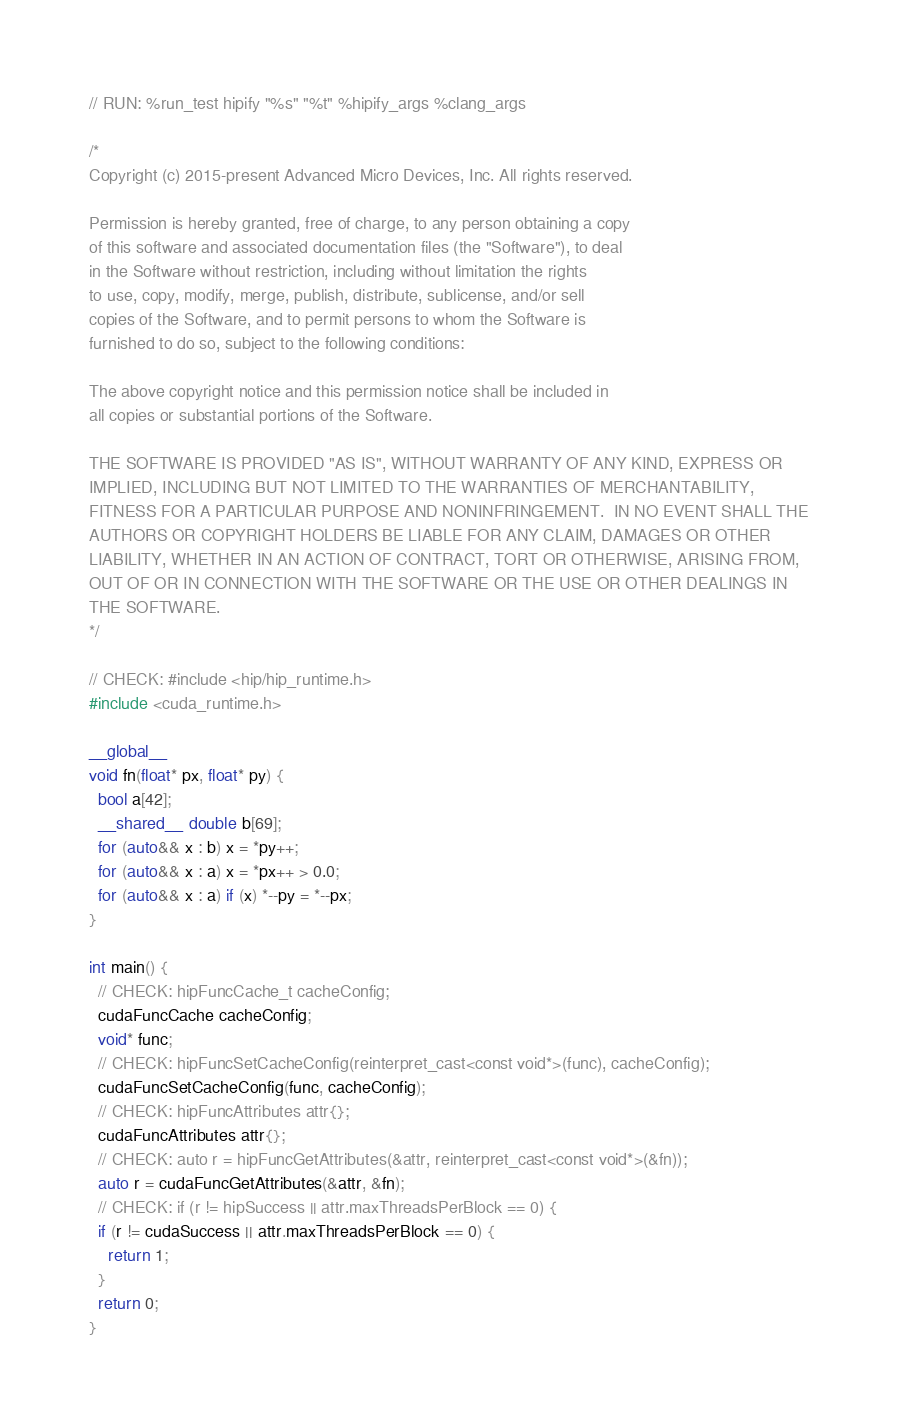<code> <loc_0><loc_0><loc_500><loc_500><_Cuda_>// RUN: %run_test hipify "%s" "%t" %hipify_args %clang_args

/*
Copyright (c) 2015-present Advanced Micro Devices, Inc. All rights reserved.

Permission is hereby granted, free of charge, to any person obtaining a copy
of this software and associated documentation files (the "Software"), to deal
in the Software without restriction, including without limitation the rights
to use, copy, modify, merge, publish, distribute, sublicense, and/or sell
copies of the Software, and to permit persons to whom the Software is
furnished to do so, subject to the following conditions:

The above copyright notice and this permission notice shall be included in
all copies or substantial portions of the Software.

THE SOFTWARE IS PROVIDED "AS IS", WITHOUT WARRANTY OF ANY KIND, EXPRESS OR
IMPLIED, INCLUDING BUT NOT LIMITED TO THE WARRANTIES OF MERCHANTABILITY,
FITNESS FOR A PARTICULAR PURPOSE AND NONINFRINGEMENT.  IN NO EVENT SHALL THE
AUTHORS OR COPYRIGHT HOLDERS BE LIABLE FOR ANY CLAIM, DAMAGES OR OTHER
LIABILITY, WHETHER IN AN ACTION OF CONTRACT, TORT OR OTHERWISE, ARISING FROM,
OUT OF OR IN CONNECTION WITH THE SOFTWARE OR THE USE OR OTHER DEALINGS IN
THE SOFTWARE.
*/

// CHECK: #include <hip/hip_runtime.h>
#include <cuda_runtime.h>

__global__
void fn(float* px, float* py) {
  bool a[42];
  __shared__ double b[69];
  for (auto&& x : b) x = *py++;
  for (auto&& x : a) x = *px++ > 0.0;
  for (auto&& x : a) if (x) *--py = *--px;
}

int main() {
  // CHECK: hipFuncCache_t cacheConfig;
  cudaFuncCache cacheConfig;
  void* func;
  // CHECK: hipFuncSetCacheConfig(reinterpret_cast<const void*>(func), cacheConfig);
  cudaFuncSetCacheConfig(func, cacheConfig);
  // CHECK: hipFuncAttributes attr{};
  cudaFuncAttributes attr{};
  // CHECK: auto r = hipFuncGetAttributes(&attr, reinterpret_cast<const void*>(&fn));
  auto r = cudaFuncGetAttributes(&attr, &fn);
  // CHECK: if (r != hipSuccess || attr.maxThreadsPerBlock == 0) {
  if (r != cudaSuccess || attr.maxThreadsPerBlock == 0) {
    return 1;
  }
  return 0;
}
</code> 